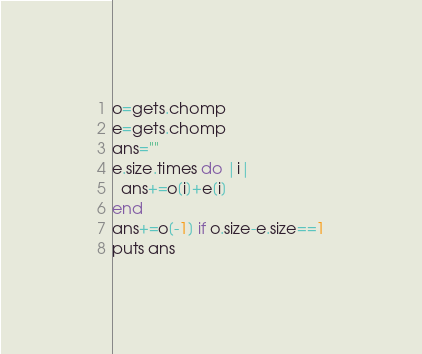Convert code to text. <code><loc_0><loc_0><loc_500><loc_500><_Ruby_>o=gets.chomp
e=gets.chomp
ans=""
e.size.times do |i|
  ans+=o[i]+e[i]
end
ans+=o[-1] if o.size-e.size==1
puts ans
</code> 